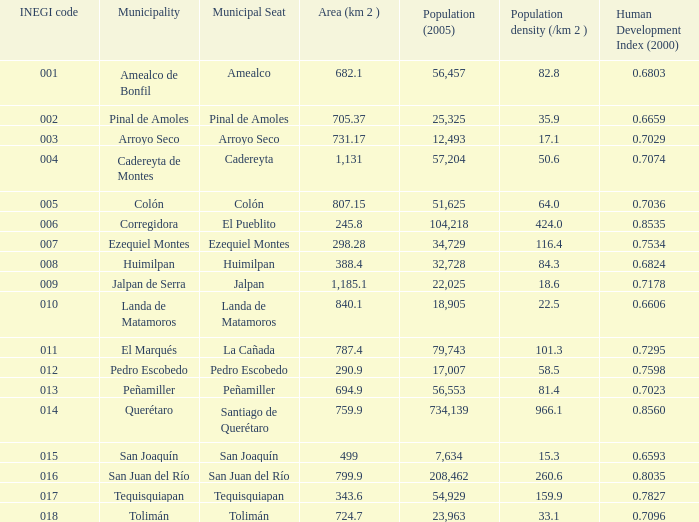4 and 15.0. 